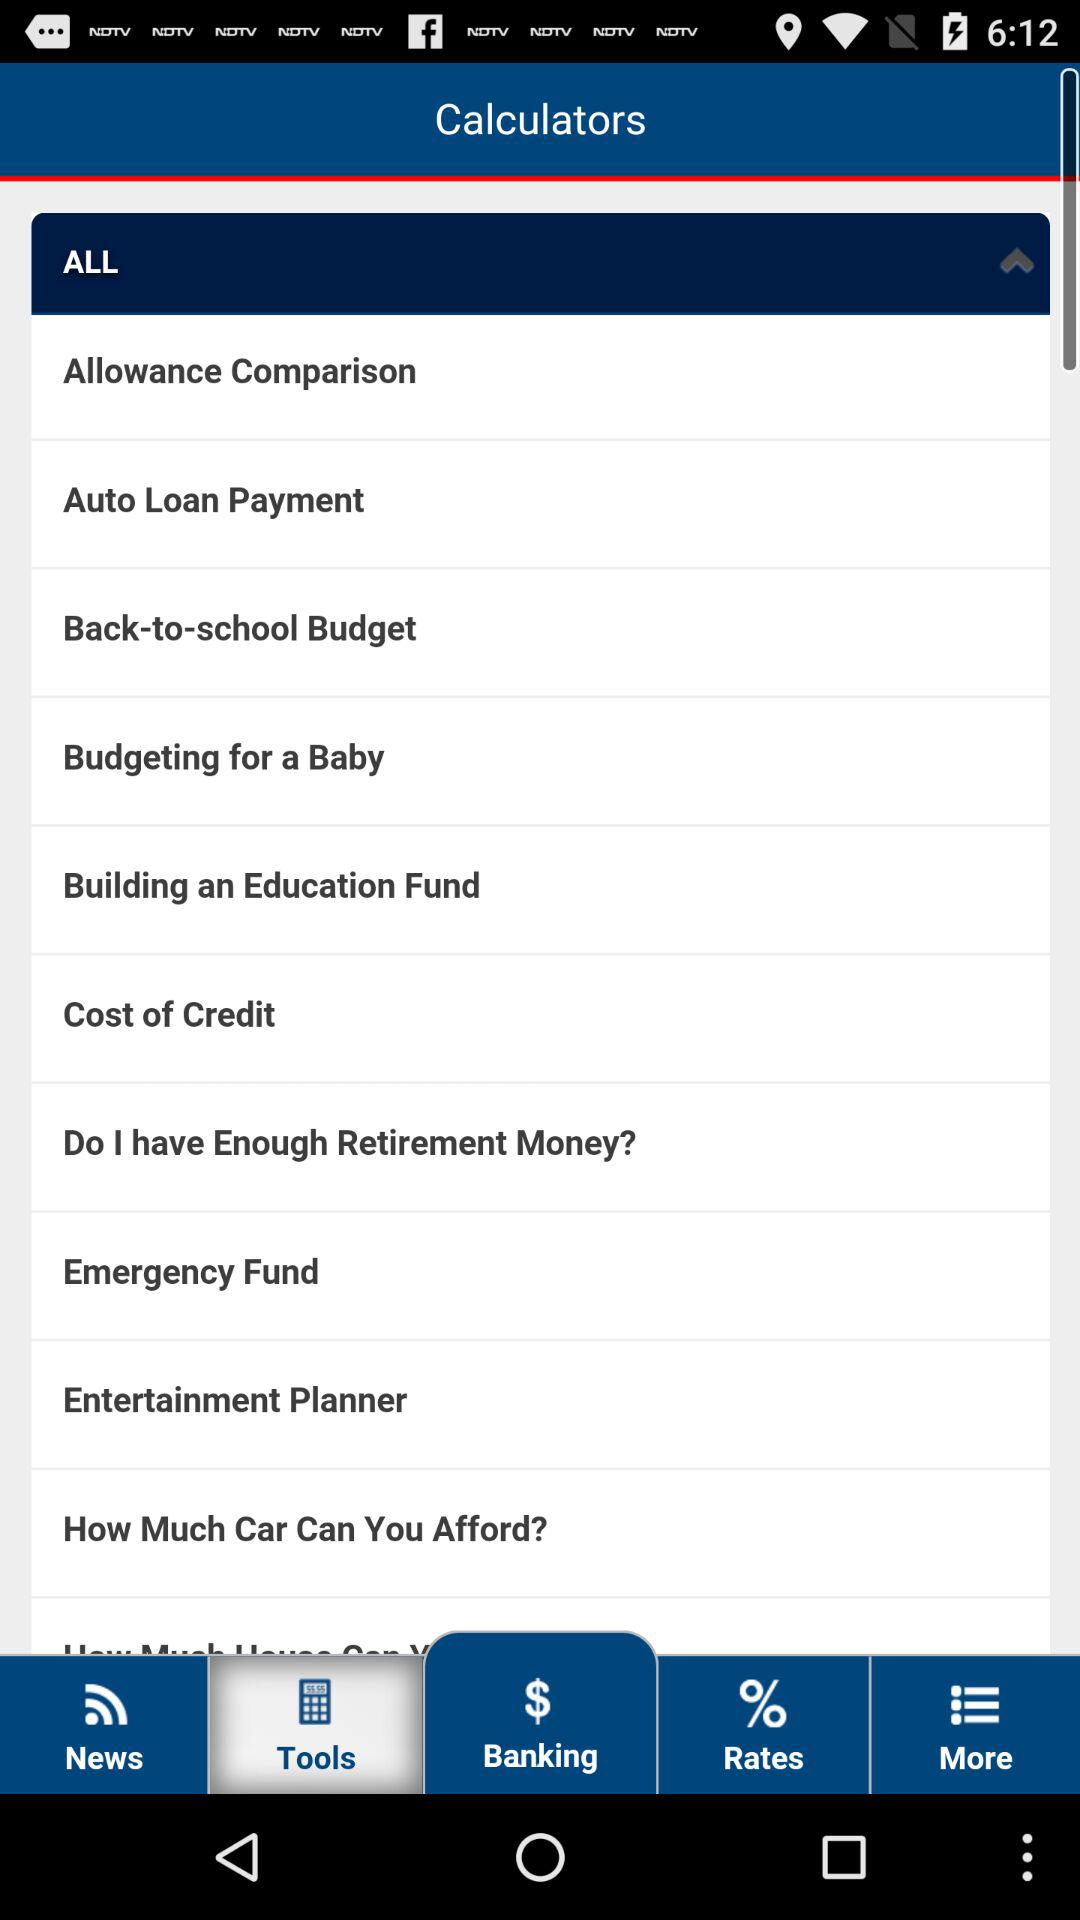What is the application name? The application name is "Calculators". 